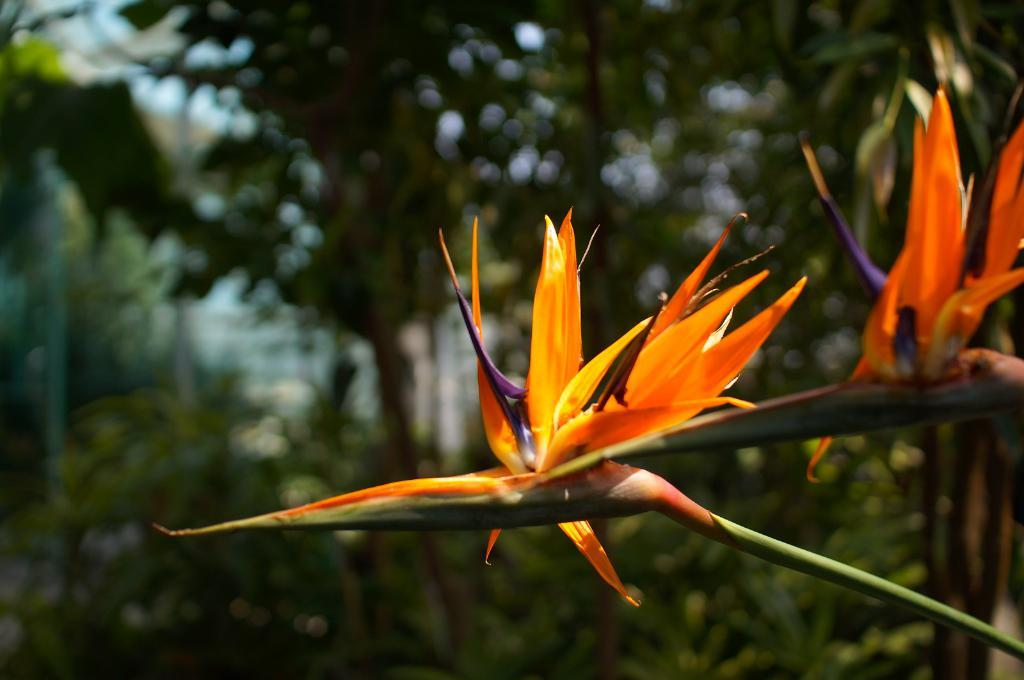What type of flowers are in the middle of the picture? There are orange color flowers in the middle of the picture. What can be seen in the background of the picture? There are trees in the background of the picture. How many kittens are playing with the match in the image? There are no kittens or matches present in the image. 